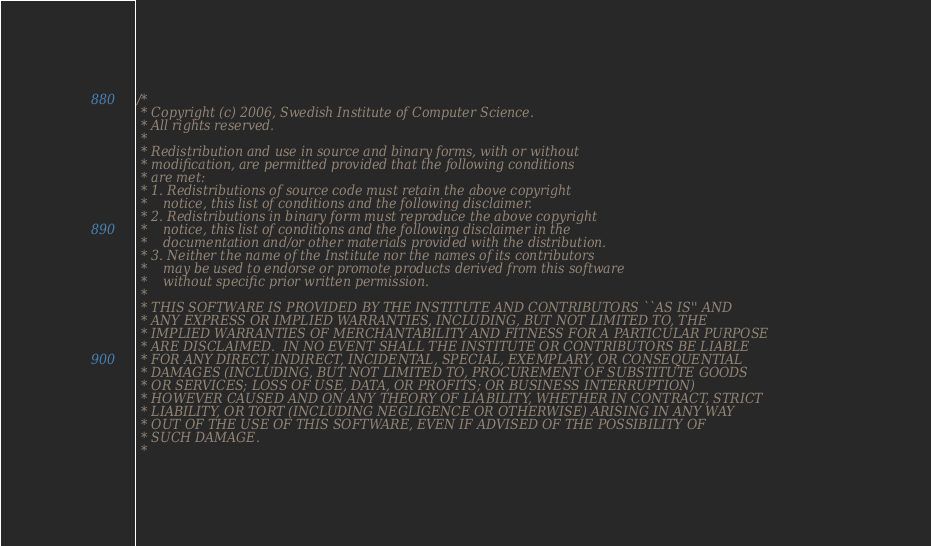Convert code to text. <code><loc_0><loc_0><loc_500><loc_500><_C_>/*
 * Copyright (c) 2006, Swedish Institute of Computer Science.
 * All rights reserved.
 *
 * Redistribution and use in source and binary forms, with or without
 * modification, are permitted provided that the following conditions
 * are met:
 * 1. Redistributions of source code must retain the above copyright
 *    notice, this list of conditions and the following disclaimer.
 * 2. Redistributions in binary form must reproduce the above copyright
 *    notice, this list of conditions and the following disclaimer in the
 *    documentation and/or other materials provided with the distribution.
 * 3. Neither the name of the Institute nor the names of its contributors
 *    may be used to endorse or promote products derived from this software
 *    without specific prior written permission.
 *
 * THIS SOFTWARE IS PROVIDED BY THE INSTITUTE AND CONTRIBUTORS ``AS IS'' AND
 * ANY EXPRESS OR IMPLIED WARRANTIES, INCLUDING, BUT NOT LIMITED TO, THE
 * IMPLIED WARRANTIES OF MERCHANTABILITY AND FITNESS FOR A PARTICULAR PURPOSE
 * ARE DISCLAIMED.  IN NO EVENT SHALL THE INSTITUTE OR CONTRIBUTORS BE LIABLE
 * FOR ANY DIRECT, INDIRECT, INCIDENTAL, SPECIAL, EXEMPLARY, OR CONSEQUENTIAL
 * DAMAGES (INCLUDING, BUT NOT LIMITED TO, PROCUREMENT OF SUBSTITUTE GOODS
 * OR SERVICES; LOSS OF USE, DATA, OR PROFITS; OR BUSINESS INTERRUPTION)
 * HOWEVER CAUSED AND ON ANY THEORY OF LIABILITY, WHETHER IN CONTRACT, STRICT
 * LIABILITY, OR TORT (INCLUDING NEGLIGENCE OR OTHERWISE) ARISING IN ANY WAY
 * OUT OF THE USE OF THIS SOFTWARE, EVEN IF ADVISED OF THE POSSIBILITY OF
 * SUCH DAMAGE.
 *</code> 